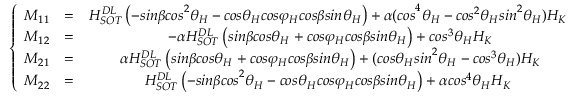Convert formula to latex. <formula><loc_0><loc_0><loc_500><loc_500>\left \{ \begin{array} { c c c } { M _ { 1 1 } } & { = } & { H _ { S O T } ^ { D L } \left ( - { \sin \beta \cos } ^ { 2 } { \theta } _ { H } - \cos { \theta } _ { H } \cos { \varphi } _ { H } \cos \beta \sin { \theta } _ { H } \right ) + { \alpha ( \cos } ^ { 4 } { \theta } _ { H } - { \cos } ^ { 2 } { \theta } _ { H } { \sin } ^ { 2 } { \theta } _ { H } ) H _ { K { \ } } } \\ { M _ { 1 2 } } & { = } & { - \alpha H _ { S O T } ^ { D L } \left ( \sin \beta \cos { \theta } _ { H } + \cos { \varphi } _ { H } \cos \beta \sin { \theta } _ { H } \right ) + { \cos } ^ { 3 } { \theta } _ { H } H _ { K } } \\ { M _ { 2 1 } } & { = } & { \alpha H _ { S O T } ^ { D L } \left ( \sin \beta \cos { \theta } _ { H } + \cos { \varphi } _ { H } \cos \beta \sin { \theta } _ { H } \right ) + ( \cos { \theta } _ { H } { \sin } ^ { 2 } { \theta } _ { H } - { \cos } ^ { 3 } { \theta } _ { H } ) H _ { K } } \\ { M _ { 2 2 } } & { = } & { H _ { S O T } ^ { D L } \left ( - { \sin \beta \cos } ^ { 2 } { \theta } _ { H } - \cos { \theta } _ { H } \cos { \varphi } _ { H } \cos \beta \sin { \theta } _ { H } \right ) + { \alpha \cos } ^ { 4 } { \theta } _ { H } H _ { K { \ } } } \end{array}</formula> 